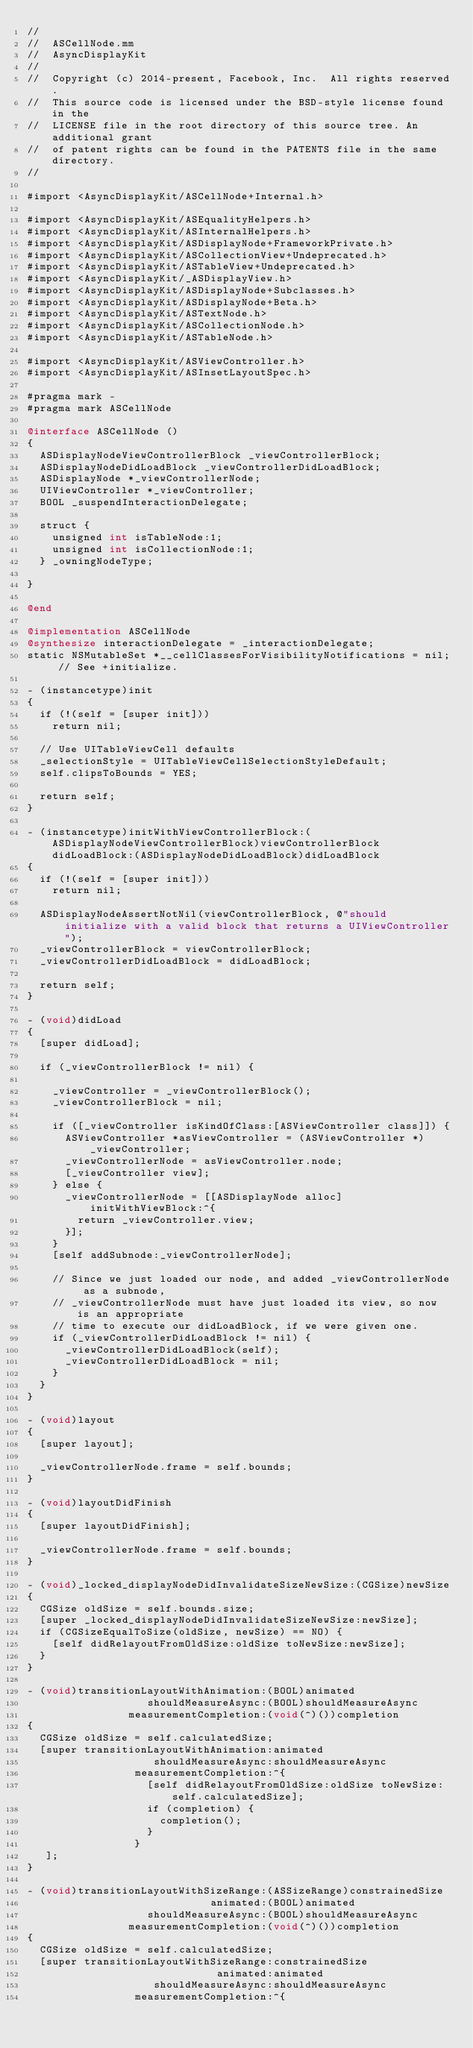Convert code to text. <code><loc_0><loc_0><loc_500><loc_500><_ObjectiveC_>//
//  ASCellNode.mm
//  AsyncDisplayKit
//
//  Copyright (c) 2014-present, Facebook, Inc.  All rights reserved.
//  This source code is licensed under the BSD-style license found in the
//  LICENSE file in the root directory of this source tree. An additional grant
//  of patent rights can be found in the PATENTS file in the same directory.
//

#import <AsyncDisplayKit/ASCellNode+Internal.h>

#import <AsyncDisplayKit/ASEqualityHelpers.h>
#import <AsyncDisplayKit/ASInternalHelpers.h>
#import <AsyncDisplayKit/ASDisplayNode+FrameworkPrivate.h>
#import <AsyncDisplayKit/ASCollectionView+Undeprecated.h>
#import <AsyncDisplayKit/ASTableView+Undeprecated.h>
#import <AsyncDisplayKit/_ASDisplayView.h>
#import <AsyncDisplayKit/ASDisplayNode+Subclasses.h>
#import <AsyncDisplayKit/ASDisplayNode+Beta.h>
#import <AsyncDisplayKit/ASTextNode.h>
#import <AsyncDisplayKit/ASCollectionNode.h>
#import <AsyncDisplayKit/ASTableNode.h>

#import <AsyncDisplayKit/ASViewController.h>
#import <AsyncDisplayKit/ASInsetLayoutSpec.h>

#pragma mark -
#pragma mark ASCellNode

@interface ASCellNode ()
{
  ASDisplayNodeViewControllerBlock _viewControllerBlock;
  ASDisplayNodeDidLoadBlock _viewControllerDidLoadBlock;
  ASDisplayNode *_viewControllerNode;
  UIViewController *_viewController;
  BOOL _suspendInteractionDelegate;

  struct {
    unsigned int isTableNode:1;
    unsigned int isCollectionNode:1;
  } _owningNodeType;

}

@end

@implementation ASCellNode
@synthesize interactionDelegate = _interactionDelegate;
static NSMutableSet *__cellClassesForVisibilityNotifications = nil; // See +initialize.

- (instancetype)init
{
  if (!(self = [super init]))
    return nil;

  // Use UITableViewCell defaults
  _selectionStyle = UITableViewCellSelectionStyleDefault;
  self.clipsToBounds = YES;

  return self;
}

- (instancetype)initWithViewControllerBlock:(ASDisplayNodeViewControllerBlock)viewControllerBlock didLoadBlock:(ASDisplayNodeDidLoadBlock)didLoadBlock
{
  if (!(self = [super init]))
    return nil;
  
  ASDisplayNodeAssertNotNil(viewControllerBlock, @"should initialize with a valid block that returns a UIViewController");
  _viewControllerBlock = viewControllerBlock;
  _viewControllerDidLoadBlock = didLoadBlock;

  return self;
}

- (void)didLoad
{
  [super didLoad];

  if (_viewControllerBlock != nil) {

    _viewController = _viewControllerBlock();
    _viewControllerBlock = nil;

    if ([_viewController isKindOfClass:[ASViewController class]]) {
      ASViewController *asViewController = (ASViewController *)_viewController;
      _viewControllerNode = asViewController.node;
      [_viewController view];
    } else {
      _viewControllerNode = [[ASDisplayNode alloc] initWithViewBlock:^{
        return _viewController.view;
      }];
    }
    [self addSubnode:_viewControllerNode];

    // Since we just loaded our node, and added _viewControllerNode as a subnode,
    // _viewControllerNode must have just loaded its view, so now is an appropriate
    // time to execute our didLoadBlock, if we were given one.
    if (_viewControllerDidLoadBlock != nil) {
      _viewControllerDidLoadBlock(self);
      _viewControllerDidLoadBlock = nil;
    }
  }
}

- (void)layout
{
  [super layout];
  
  _viewControllerNode.frame = self.bounds;
}

- (void)layoutDidFinish
{
  [super layoutDidFinish];

  _viewControllerNode.frame = self.bounds;
}

- (void)_locked_displayNodeDidInvalidateSizeNewSize:(CGSize)newSize
{
  CGSize oldSize = self.bounds.size;
  [super _locked_displayNodeDidInvalidateSizeNewSize:newSize];
  if (CGSizeEqualToSize(oldSize, newSize) == NO) {
    [self didRelayoutFromOldSize:oldSize toNewSize:newSize];
  }
}

- (void)transitionLayoutWithAnimation:(BOOL)animated
                   shouldMeasureAsync:(BOOL)shouldMeasureAsync
                measurementCompletion:(void(^)())completion
{
  CGSize oldSize = self.calculatedSize;
  [super transitionLayoutWithAnimation:animated
                    shouldMeasureAsync:shouldMeasureAsync
                 measurementCompletion:^{
                   [self didRelayoutFromOldSize:oldSize toNewSize:self.calculatedSize];
                   if (completion) {
                     completion();
                   }
                 }
   ];
}

- (void)transitionLayoutWithSizeRange:(ASSizeRange)constrainedSize
                             animated:(BOOL)animated
                   shouldMeasureAsync:(BOOL)shouldMeasureAsync
                measurementCompletion:(void(^)())completion
{
  CGSize oldSize = self.calculatedSize;
  [super transitionLayoutWithSizeRange:constrainedSize
                              animated:animated
                    shouldMeasureAsync:shouldMeasureAsync
                 measurementCompletion:^{</code> 